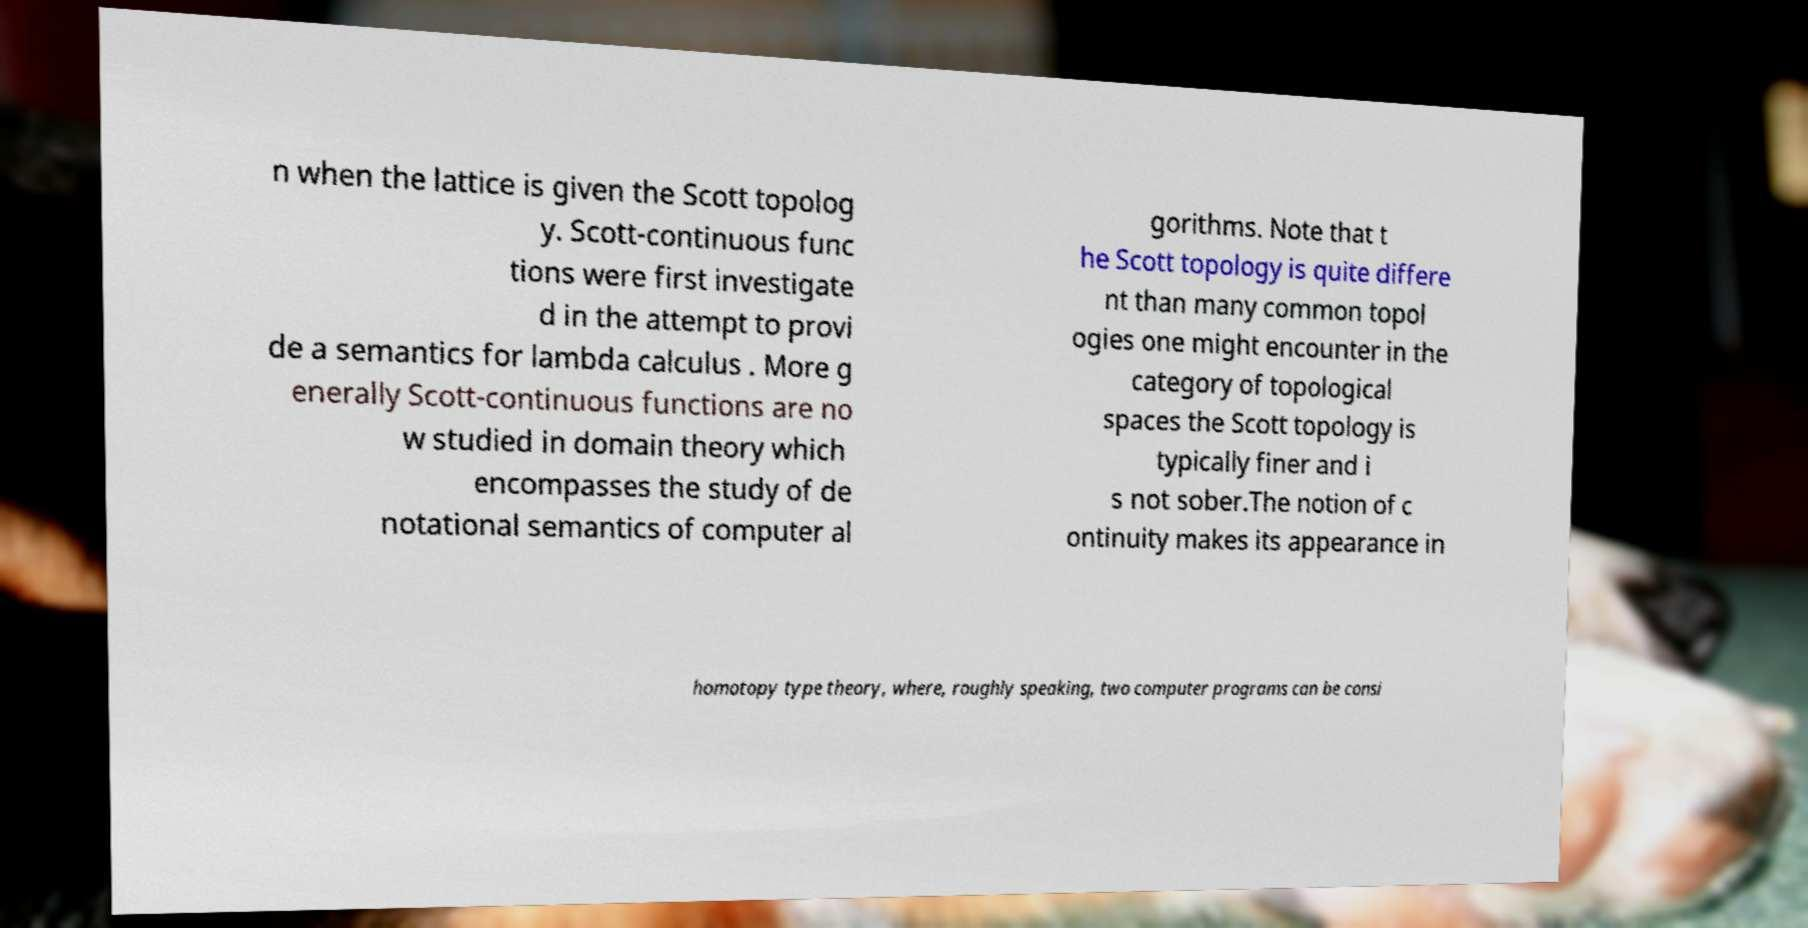Could you extract and type out the text from this image? n when the lattice is given the Scott topolog y. Scott-continuous func tions were first investigate d in the attempt to provi de a semantics for lambda calculus . More g enerally Scott-continuous functions are no w studied in domain theory which encompasses the study of de notational semantics of computer al gorithms. Note that t he Scott topology is quite differe nt than many common topol ogies one might encounter in the category of topological spaces the Scott topology is typically finer and i s not sober.The notion of c ontinuity makes its appearance in homotopy type theory, where, roughly speaking, two computer programs can be consi 